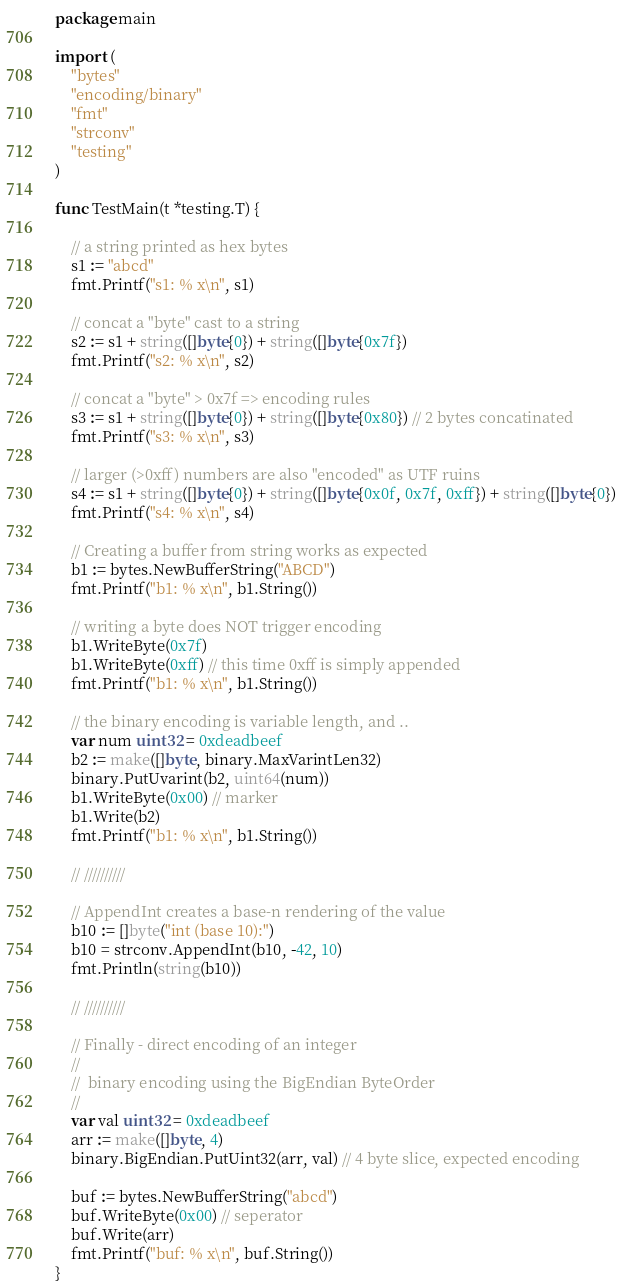<code> <loc_0><loc_0><loc_500><loc_500><_Go_>package main

import (
	"bytes"
	"encoding/binary"
	"fmt"
	"strconv"
	"testing"
)

func TestMain(t *testing.T) {

	// a string printed as hex bytes
	s1 := "abcd"
	fmt.Printf("s1: % x\n", s1)

	// concat a "byte" cast to a string
	s2 := s1 + string([]byte{0}) + string([]byte{0x7f})
	fmt.Printf("s2: % x\n", s2)

	// concat a "byte" > 0x7f => encoding rules
	s3 := s1 + string([]byte{0}) + string([]byte{0x80}) // 2 bytes concatinated
	fmt.Printf("s3: % x\n", s3)

	// larger (>0xff) numbers are also "encoded" as UTF ruins
	s4 := s1 + string([]byte{0}) + string([]byte{0x0f, 0x7f, 0xff}) + string([]byte{0})
	fmt.Printf("s4: % x\n", s4)

	// Creating a buffer from string works as expected
	b1 := bytes.NewBufferString("ABCD")
	fmt.Printf("b1: % x\n", b1.String())

	// writing a byte does NOT trigger encoding
	b1.WriteByte(0x7f)
	b1.WriteByte(0xff) // this time 0xff is simply appended
	fmt.Printf("b1: % x\n", b1.String())

	// the binary encoding is variable length, and ..
	var num uint32 = 0xdeadbeef
	b2 := make([]byte, binary.MaxVarintLen32)
	binary.PutUvarint(b2, uint64(num))
	b1.WriteByte(0x00) // marker
	b1.Write(b2)
	fmt.Printf("b1: % x\n", b1.String())

	// //////////

	// AppendInt creates a base-n rendering of the value
	b10 := []byte("int (base 10):")
	b10 = strconv.AppendInt(b10, -42, 10)
	fmt.Println(string(b10))

	// //////////

	// Finally - direct encoding of an integer
	//
	//  binary encoding using the BigEndian ByteOrder
	//
	var val uint32 = 0xdeadbeef
	arr := make([]byte, 4)
	binary.BigEndian.PutUint32(arr, val) // 4 byte slice, expected encoding

	buf := bytes.NewBufferString("abcd")
	buf.WriteByte(0x00) // seperator
	buf.Write(arr)
	fmt.Printf("buf: % x\n", buf.String())
}
</code> 